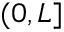Convert formula to latex. <formula><loc_0><loc_0><loc_500><loc_500>( 0 , L ]</formula> 